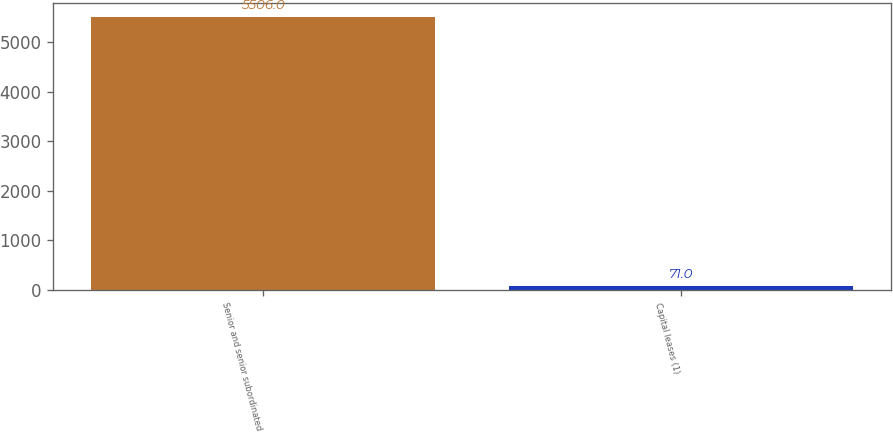Convert chart. <chart><loc_0><loc_0><loc_500><loc_500><bar_chart><fcel>Senior and senior subordinated<fcel>Capital leases (1)<nl><fcel>5506<fcel>71<nl></chart> 